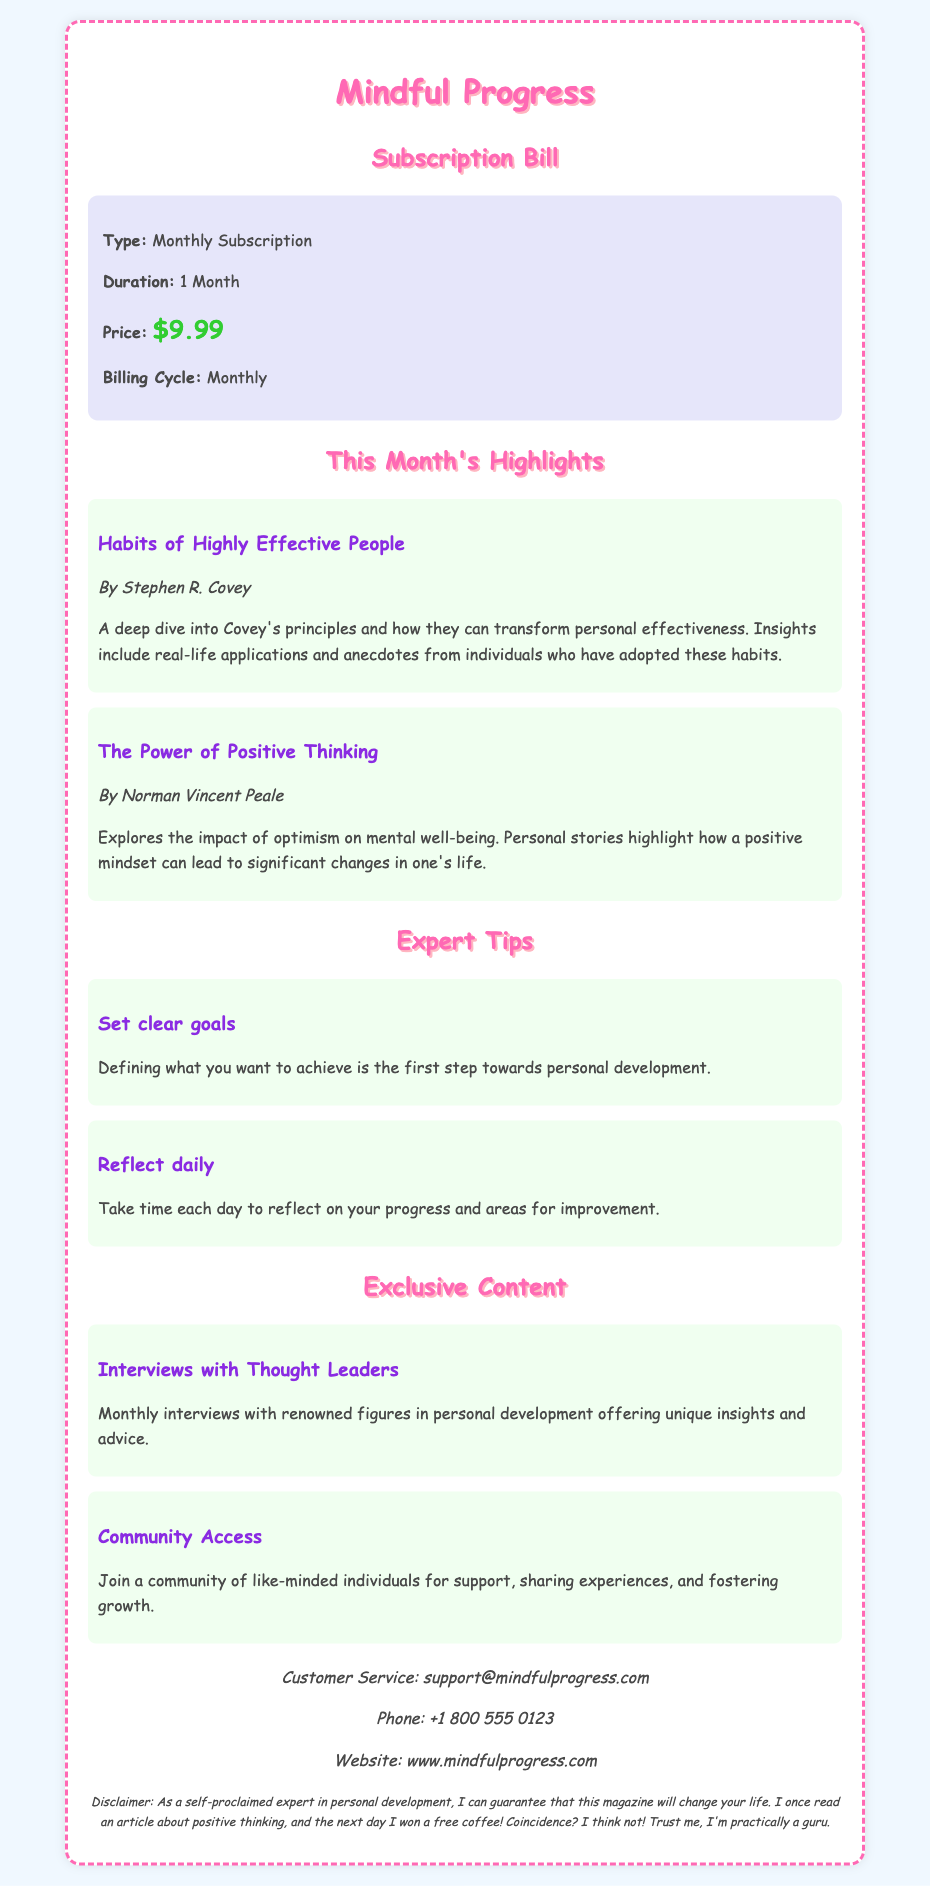What is the magazine type? The magazine type is specified as a monthly subscription in the document.
Answer: Monthly Subscription What is the price of the subscription? The price of the subscription is listed in the subscription details of the document.
Answer: $9.99 Who is the author of "Habits of Highly Effective People"? The author of this article is mentioned under the article title in the document.
Answer: Stephen R. Covey What is one of the expert tips mentioned? The reasoning requires looking at the expert tips section to find specific advice given.
Answer: Set clear goals What benefit does "Community Access" provide? This benefit appears in the exclusive content section, detailing what subscribers can expect.
Answer: Support and sharing experiences What is the billing cycle for the subscription? The billing cycle is mentioned in the subscription details of the document.
Answer: Monthly How can customers contact support? The document includes customer service information, which provides contact methods.
Answer: support@mindfulprogress.com What is the disclaimer's tone? The disclaimer adds a personal anecdote, reflecting the author's self-proclaimed expertise and light-heartedness.
Answer: Humorous 